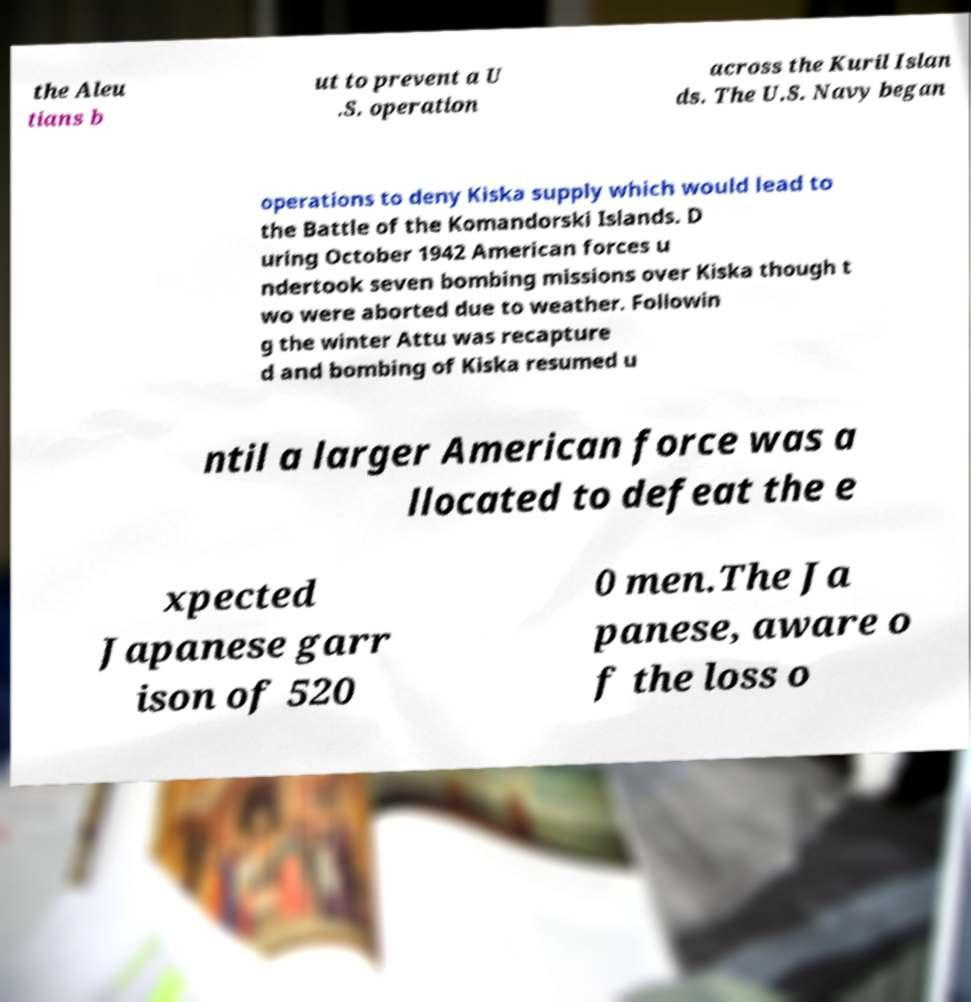What messages or text are displayed in this image? I need them in a readable, typed format. the Aleu tians b ut to prevent a U .S. operation across the Kuril Islan ds. The U.S. Navy began operations to deny Kiska supply which would lead to the Battle of the Komandorski Islands. D uring October 1942 American forces u ndertook seven bombing missions over Kiska though t wo were aborted due to weather. Followin g the winter Attu was recapture d and bombing of Kiska resumed u ntil a larger American force was a llocated to defeat the e xpected Japanese garr ison of 520 0 men.The Ja panese, aware o f the loss o 